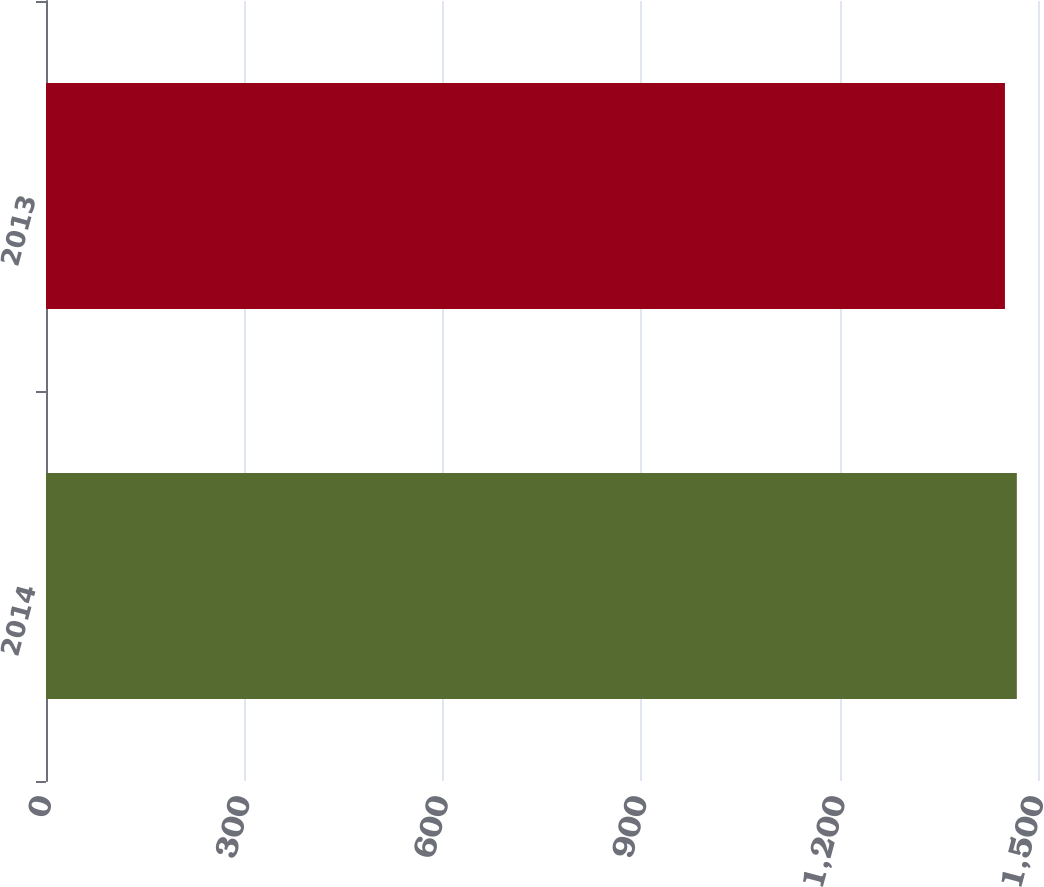Convert chart. <chart><loc_0><loc_0><loc_500><loc_500><bar_chart><fcel>2014<fcel>2013<nl><fcel>1468<fcel>1450<nl></chart> 